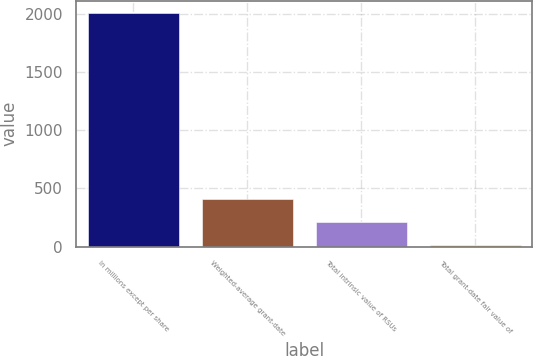Convert chart to OTSL. <chart><loc_0><loc_0><loc_500><loc_500><bar_chart><fcel>In millions except per share<fcel>Weighted-average grant-date<fcel>Total intrinsic value of RSUs<fcel>Total grant-date fair value of<nl><fcel>2013<fcel>413.32<fcel>213.36<fcel>13.4<nl></chart> 